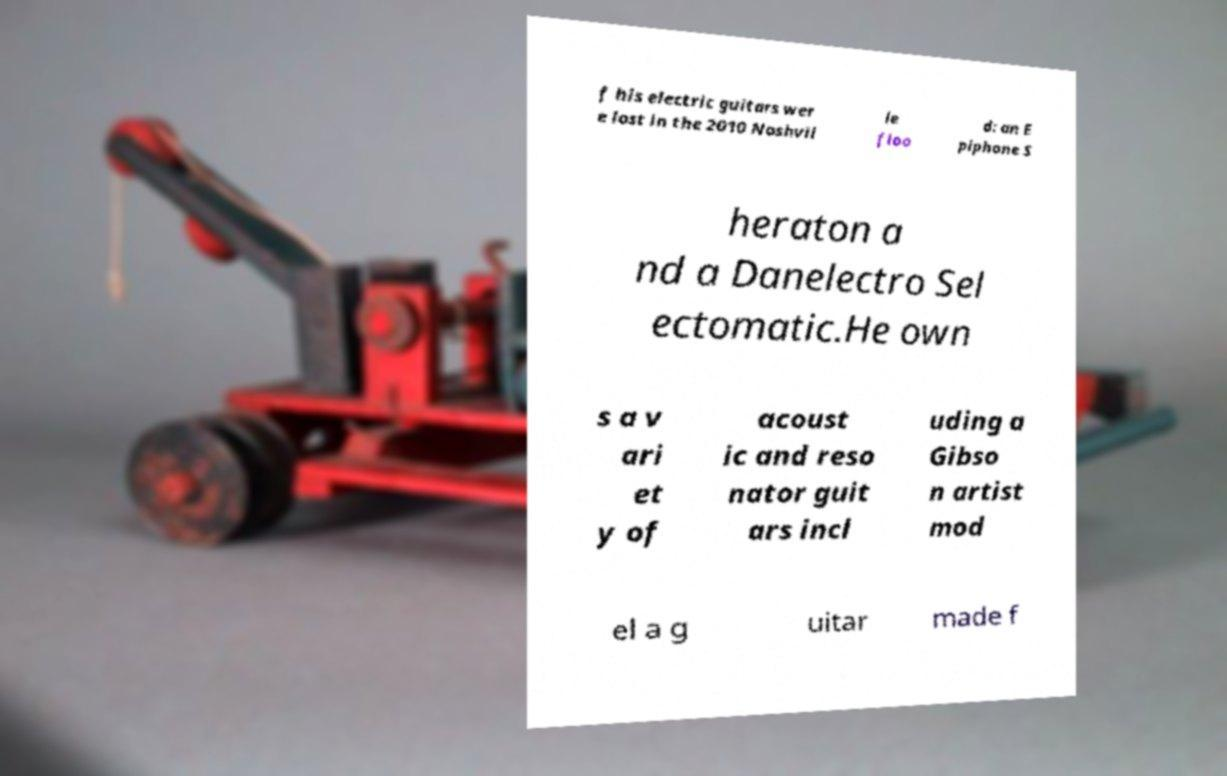I need the written content from this picture converted into text. Can you do that? f his electric guitars wer e lost in the 2010 Nashvil le floo d: an E piphone S heraton a nd a Danelectro Sel ectomatic.He own s a v ari et y of acoust ic and reso nator guit ars incl uding a Gibso n artist mod el a g uitar made f 